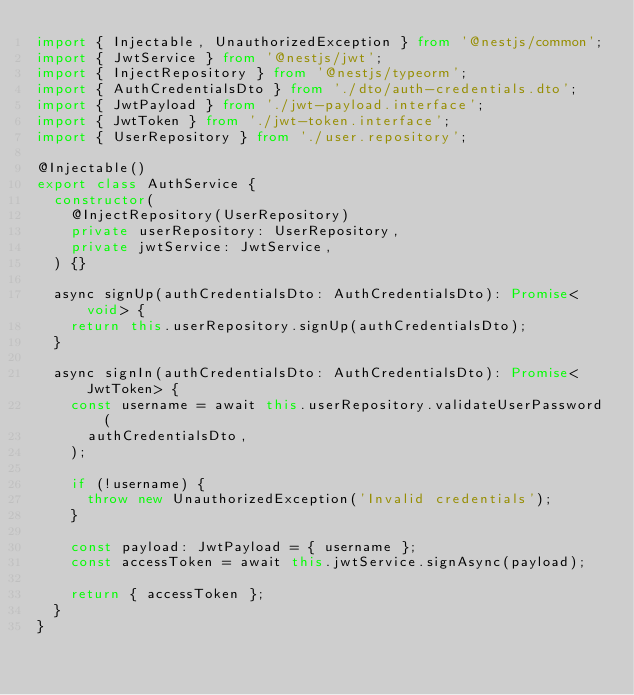<code> <loc_0><loc_0><loc_500><loc_500><_TypeScript_>import { Injectable, UnauthorizedException } from '@nestjs/common';
import { JwtService } from '@nestjs/jwt';
import { InjectRepository } from '@nestjs/typeorm';
import { AuthCredentialsDto } from './dto/auth-credentials.dto';
import { JwtPayload } from './jwt-payload.interface';
import { JwtToken } from './jwt-token.interface';
import { UserRepository } from './user.repository';

@Injectable()
export class AuthService {
  constructor(
    @InjectRepository(UserRepository)
    private userRepository: UserRepository,
    private jwtService: JwtService,
  ) {}

  async signUp(authCredentialsDto: AuthCredentialsDto): Promise<void> {
    return this.userRepository.signUp(authCredentialsDto);
  }

  async signIn(authCredentialsDto: AuthCredentialsDto): Promise<JwtToken> {
    const username = await this.userRepository.validateUserPassword(
      authCredentialsDto,
    );

    if (!username) {
      throw new UnauthorizedException('Invalid credentials');
    }

    const payload: JwtPayload = { username };
    const accessToken = await this.jwtService.signAsync(payload);

    return { accessToken };
  }
}
</code> 